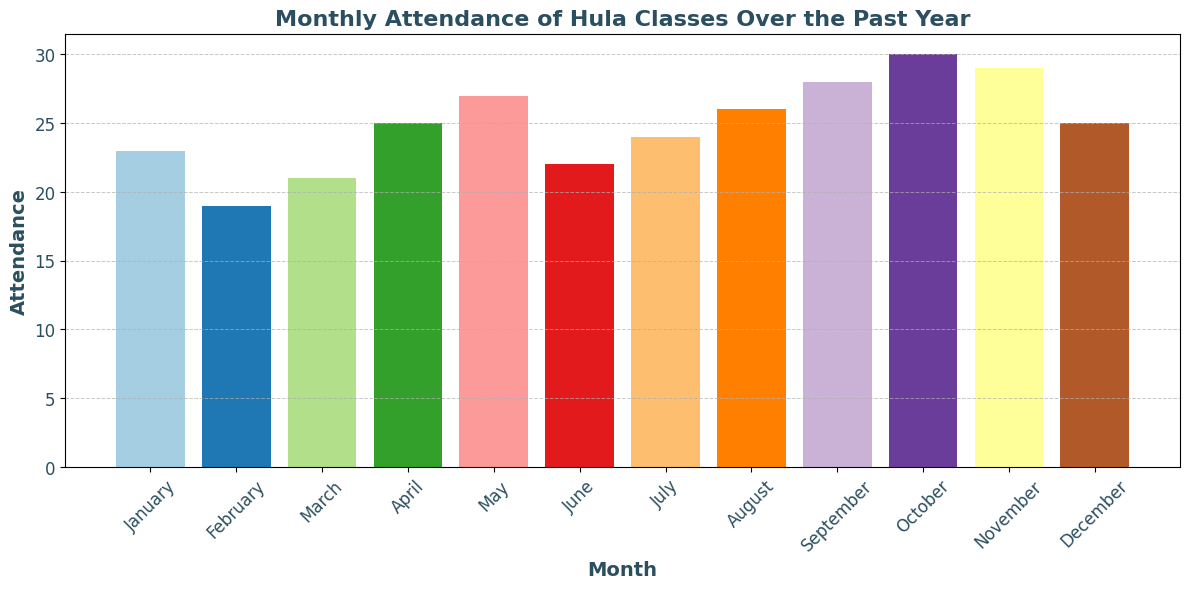Which month had the highest attendance? By looking at the heights of the bars, we can see the month with the tallest bar has the highest attendance. In this case, October has the tallest bar.
Answer: October Which month had the lowest attendance? By checking the bars with the lowest height, we see that February has the shortest bar, indicating the lowest attendance.
Answer: February What's the difference in attendance between the month with the highest attendance and the month with the lowest attendance? October had the highest attendance with 30, and February had the lowest with 19. The difference is calculated by subtracting 19 from 30.
Answer: 11 How many months had an attendance greater than 25? By counting the bars that surpass the height corresponding to 25, we notice that four months (May, August, September, October, and November) have attendance greater than 25.
Answer: 5 What's the average attendance over the entire year? Sum all the monthly attendance values: 23 + 19 + 21 + 25 + 27 + 22 + 24 + 26 + 28 + 30 + 29 + 25 = 299. Then, divide by the number of months, which is 12: 299/12 = roughly 24.92.
Answer: ~24.92 Which months have an equal attendance value? By examining the height of the bars, we see that April and December both display bars with the same height, each indicating an attendance of 25.
Answer: April and December What is the median attendance for the year? To find the median, first list attendance values in ascending order: 19, 21, 22, 23, 24, 25, 25, 26, 27, 28, 29, 30. Since there are 12 values, the median is the average of the 6th and 7th values. Thus, (25 + 25)/2 = 25.
Answer: 25 During which quarter did the attendance show the most variation? Comparing the variation (difference between maximum and minimum) of each quarter: 
Q1 (Jan, Feb, Mar): 23-19 = 4
Q2 (Apr, May, Jun): 27-22 = 5
Q3 (Jul, Aug, Sep): 28-24 = 4
Q4 (Oct, Nov, Dec): 30-25 = 5
Both Q2 and Q4 have the highest variation with a difference of 5.
Answer: Q2 and Q4 What is the total attendance in the second half of the year (July to December)? Sum the attendance values from July to December: 24 (Jul) + 26 (Aug) + 28 (Sep) + 30 (Oct) + 29 (Nov) + 25 (Dec) = 162.
Answer: 162 